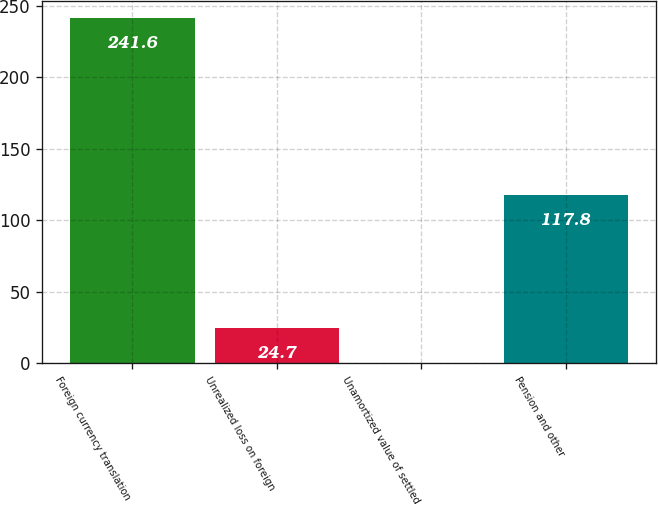Convert chart. <chart><loc_0><loc_0><loc_500><loc_500><bar_chart><fcel>Foreign currency translation<fcel>Unrealized loss on foreign<fcel>Unamortized value of settled<fcel>Pension and other<nl><fcel>241.6<fcel>24.7<fcel>0.6<fcel>117.8<nl></chart> 